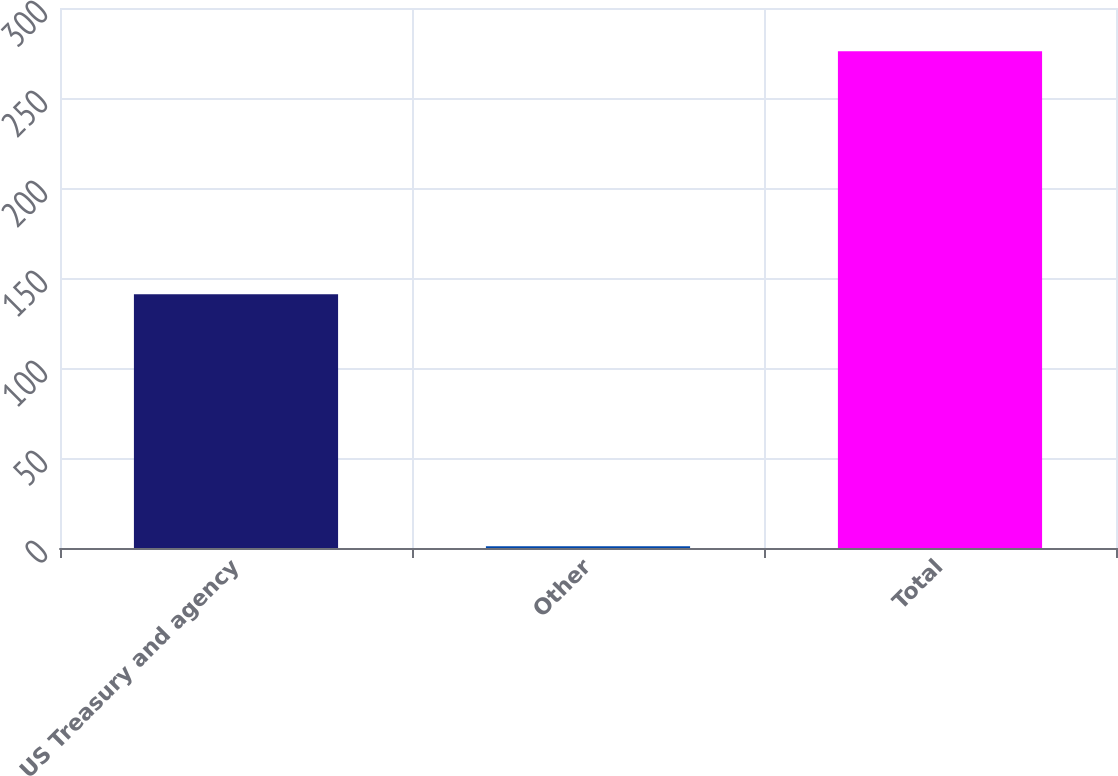Convert chart. <chart><loc_0><loc_0><loc_500><loc_500><bar_chart><fcel>US Treasury and agency<fcel>Other<fcel>Total<nl><fcel>141<fcel>1<fcel>276<nl></chart> 